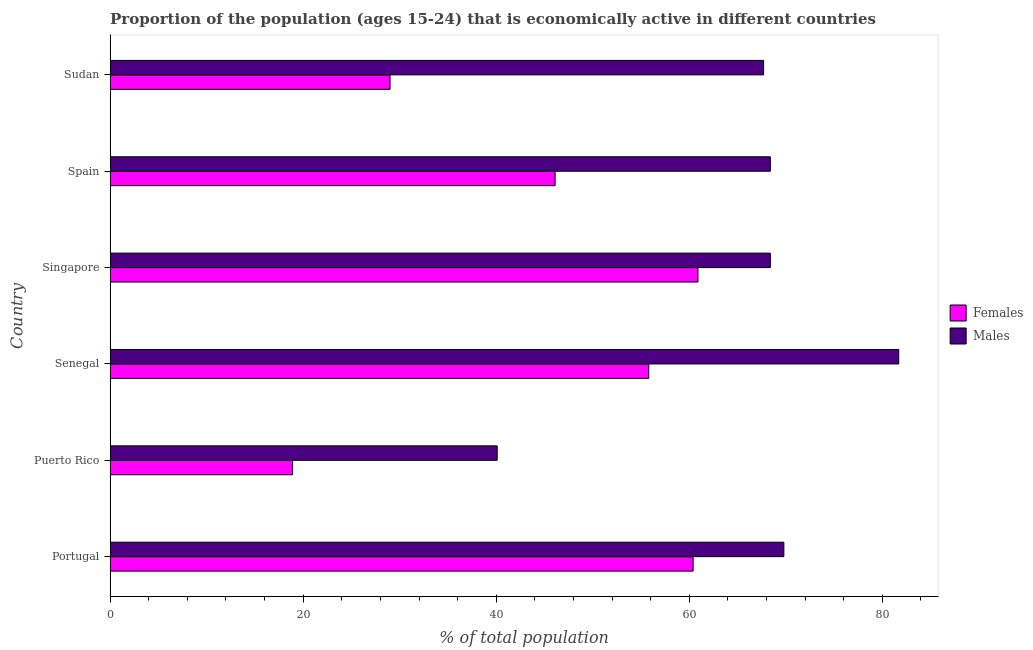How many different coloured bars are there?
Offer a terse response. 2. How many groups of bars are there?
Give a very brief answer. 6. Are the number of bars per tick equal to the number of legend labels?
Give a very brief answer. Yes. How many bars are there on the 6th tick from the top?
Provide a short and direct response. 2. What is the label of the 5th group of bars from the top?
Your answer should be compact. Puerto Rico. In how many cases, is the number of bars for a given country not equal to the number of legend labels?
Your answer should be very brief. 0. What is the percentage of economically active male population in Spain?
Offer a terse response. 68.4. Across all countries, what is the maximum percentage of economically active female population?
Provide a succinct answer. 60.9. Across all countries, what is the minimum percentage of economically active female population?
Make the answer very short. 18.9. In which country was the percentage of economically active male population maximum?
Your answer should be very brief. Senegal. In which country was the percentage of economically active female population minimum?
Ensure brevity in your answer.  Puerto Rico. What is the total percentage of economically active male population in the graph?
Ensure brevity in your answer.  396.1. What is the difference between the percentage of economically active female population in Puerto Rico and that in Spain?
Give a very brief answer. -27.2. What is the difference between the percentage of economically active female population in Sudan and the percentage of economically active male population in Senegal?
Ensure brevity in your answer.  -52.7. What is the average percentage of economically active male population per country?
Provide a short and direct response. 66.02. What is the difference between the percentage of economically active male population and percentage of economically active female population in Sudan?
Your answer should be very brief. 38.7. Is the difference between the percentage of economically active female population in Senegal and Spain greater than the difference between the percentage of economically active male population in Senegal and Spain?
Make the answer very short. No. What is the difference between the highest and the lowest percentage of economically active male population?
Give a very brief answer. 41.6. In how many countries, is the percentage of economically active female population greater than the average percentage of economically active female population taken over all countries?
Make the answer very short. 4. Is the sum of the percentage of economically active male population in Portugal and Senegal greater than the maximum percentage of economically active female population across all countries?
Your answer should be compact. Yes. What does the 2nd bar from the top in Spain represents?
Provide a short and direct response. Females. What does the 1st bar from the bottom in Sudan represents?
Give a very brief answer. Females. How many countries are there in the graph?
Your answer should be compact. 6. Does the graph contain any zero values?
Ensure brevity in your answer.  No. Where does the legend appear in the graph?
Ensure brevity in your answer.  Center right. How many legend labels are there?
Your answer should be compact. 2. What is the title of the graph?
Your answer should be compact. Proportion of the population (ages 15-24) that is economically active in different countries. Does "Overweight" appear as one of the legend labels in the graph?
Your answer should be very brief. No. What is the label or title of the X-axis?
Make the answer very short. % of total population. What is the % of total population of Females in Portugal?
Provide a short and direct response. 60.4. What is the % of total population of Males in Portugal?
Offer a very short reply. 69.8. What is the % of total population in Females in Puerto Rico?
Provide a succinct answer. 18.9. What is the % of total population in Males in Puerto Rico?
Your answer should be very brief. 40.1. What is the % of total population of Females in Senegal?
Ensure brevity in your answer.  55.8. What is the % of total population in Males in Senegal?
Ensure brevity in your answer.  81.7. What is the % of total population in Females in Singapore?
Provide a short and direct response. 60.9. What is the % of total population in Males in Singapore?
Provide a succinct answer. 68.4. What is the % of total population of Females in Spain?
Your response must be concise. 46.1. What is the % of total population in Males in Spain?
Give a very brief answer. 68.4. What is the % of total population in Females in Sudan?
Offer a terse response. 29. What is the % of total population in Males in Sudan?
Your answer should be compact. 67.7. Across all countries, what is the maximum % of total population in Females?
Ensure brevity in your answer.  60.9. Across all countries, what is the maximum % of total population in Males?
Provide a short and direct response. 81.7. Across all countries, what is the minimum % of total population in Females?
Keep it short and to the point. 18.9. Across all countries, what is the minimum % of total population of Males?
Provide a short and direct response. 40.1. What is the total % of total population in Females in the graph?
Your answer should be compact. 271.1. What is the total % of total population in Males in the graph?
Provide a succinct answer. 396.1. What is the difference between the % of total population in Females in Portugal and that in Puerto Rico?
Keep it short and to the point. 41.5. What is the difference between the % of total population of Males in Portugal and that in Puerto Rico?
Provide a succinct answer. 29.7. What is the difference between the % of total population in Females in Portugal and that in Senegal?
Provide a succinct answer. 4.6. What is the difference between the % of total population in Males in Portugal and that in Senegal?
Ensure brevity in your answer.  -11.9. What is the difference between the % of total population in Females in Portugal and that in Singapore?
Offer a terse response. -0.5. What is the difference between the % of total population in Males in Portugal and that in Singapore?
Your answer should be compact. 1.4. What is the difference between the % of total population of Males in Portugal and that in Spain?
Provide a short and direct response. 1.4. What is the difference between the % of total population of Females in Portugal and that in Sudan?
Make the answer very short. 31.4. What is the difference between the % of total population in Females in Puerto Rico and that in Senegal?
Keep it short and to the point. -36.9. What is the difference between the % of total population in Males in Puerto Rico and that in Senegal?
Provide a short and direct response. -41.6. What is the difference between the % of total population of Females in Puerto Rico and that in Singapore?
Provide a short and direct response. -42. What is the difference between the % of total population in Males in Puerto Rico and that in Singapore?
Your response must be concise. -28.3. What is the difference between the % of total population in Females in Puerto Rico and that in Spain?
Ensure brevity in your answer.  -27.2. What is the difference between the % of total population of Males in Puerto Rico and that in Spain?
Your response must be concise. -28.3. What is the difference between the % of total population in Males in Puerto Rico and that in Sudan?
Provide a short and direct response. -27.6. What is the difference between the % of total population in Females in Senegal and that in Singapore?
Keep it short and to the point. -5.1. What is the difference between the % of total population in Females in Senegal and that in Sudan?
Your response must be concise. 26.8. What is the difference between the % of total population in Females in Singapore and that in Sudan?
Your response must be concise. 31.9. What is the difference between the % of total population in Females in Spain and that in Sudan?
Offer a terse response. 17.1. What is the difference between the % of total population in Females in Portugal and the % of total population in Males in Puerto Rico?
Your answer should be compact. 20.3. What is the difference between the % of total population of Females in Portugal and the % of total population of Males in Senegal?
Your response must be concise. -21.3. What is the difference between the % of total population of Females in Portugal and the % of total population of Males in Sudan?
Give a very brief answer. -7.3. What is the difference between the % of total population of Females in Puerto Rico and the % of total population of Males in Senegal?
Provide a succinct answer. -62.8. What is the difference between the % of total population in Females in Puerto Rico and the % of total population in Males in Singapore?
Your answer should be very brief. -49.5. What is the difference between the % of total population of Females in Puerto Rico and the % of total population of Males in Spain?
Your answer should be very brief. -49.5. What is the difference between the % of total population of Females in Puerto Rico and the % of total population of Males in Sudan?
Ensure brevity in your answer.  -48.8. What is the difference between the % of total population in Females in Senegal and the % of total population in Males in Singapore?
Provide a short and direct response. -12.6. What is the difference between the % of total population of Females in Senegal and the % of total population of Males in Spain?
Make the answer very short. -12.6. What is the difference between the % of total population of Females in Senegal and the % of total population of Males in Sudan?
Ensure brevity in your answer.  -11.9. What is the difference between the % of total population of Females in Singapore and the % of total population of Males in Spain?
Make the answer very short. -7.5. What is the difference between the % of total population of Females in Singapore and the % of total population of Males in Sudan?
Make the answer very short. -6.8. What is the difference between the % of total population of Females in Spain and the % of total population of Males in Sudan?
Make the answer very short. -21.6. What is the average % of total population of Females per country?
Offer a terse response. 45.18. What is the average % of total population of Males per country?
Keep it short and to the point. 66.02. What is the difference between the % of total population in Females and % of total population in Males in Portugal?
Your response must be concise. -9.4. What is the difference between the % of total population in Females and % of total population in Males in Puerto Rico?
Your answer should be compact. -21.2. What is the difference between the % of total population of Females and % of total population of Males in Senegal?
Ensure brevity in your answer.  -25.9. What is the difference between the % of total population in Females and % of total population in Males in Singapore?
Your answer should be very brief. -7.5. What is the difference between the % of total population in Females and % of total population in Males in Spain?
Provide a succinct answer. -22.3. What is the difference between the % of total population of Females and % of total population of Males in Sudan?
Offer a terse response. -38.7. What is the ratio of the % of total population in Females in Portugal to that in Puerto Rico?
Your response must be concise. 3.2. What is the ratio of the % of total population in Males in Portugal to that in Puerto Rico?
Give a very brief answer. 1.74. What is the ratio of the % of total population in Females in Portugal to that in Senegal?
Offer a very short reply. 1.08. What is the ratio of the % of total population in Males in Portugal to that in Senegal?
Keep it short and to the point. 0.85. What is the ratio of the % of total population in Males in Portugal to that in Singapore?
Provide a short and direct response. 1.02. What is the ratio of the % of total population of Females in Portugal to that in Spain?
Make the answer very short. 1.31. What is the ratio of the % of total population in Males in Portugal to that in Spain?
Keep it short and to the point. 1.02. What is the ratio of the % of total population of Females in Portugal to that in Sudan?
Provide a succinct answer. 2.08. What is the ratio of the % of total population in Males in Portugal to that in Sudan?
Ensure brevity in your answer.  1.03. What is the ratio of the % of total population of Females in Puerto Rico to that in Senegal?
Offer a very short reply. 0.34. What is the ratio of the % of total population in Males in Puerto Rico to that in Senegal?
Give a very brief answer. 0.49. What is the ratio of the % of total population in Females in Puerto Rico to that in Singapore?
Keep it short and to the point. 0.31. What is the ratio of the % of total population of Males in Puerto Rico to that in Singapore?
Provide a succinct answer. 0.59. What is the ratio of the % of total population in Females in Puerto Rico to that in Spain?
Keep it short and to the point. 0.41. What is the ratio of the % of total population in Males in Puerto Rico to that in Spain?
Make the answer very short. 0.59. What is the ratio of the % of total population in Females in Puerto Rico to that in Sudan?
Make the answer very short. 0.65. What is the ratio of the % of total population in Males in Puerto Rico to that in Sudan?
Your answer should be very brief. 0.59. What is the ratio of the % of total population of Females in Senegal to that in Singapore?
Your answer should be very brief. 0.92. What is the ratio of the % of total population of Males in Senegal to that in Singapore?
Offer a terse response. 1.19. What is the ratio of the % of total population in Females in Senegal to that in Spain?
Provide a short and direct response. 1.21. What is the ratio of the % of total population in Males in Senegal to that in Spain?
Provide a short and direct response. 1.19. What is the ratio of the % of total population in Females in Senegal to that in Sudan?
Ensure brevity in your answer.  1.92. What is the ratio of the % of total population of Males in Senegal to that in Sudan?
Ensure brevity in your answer.  1.21. What is the ratio of the % of total population in Females in Singapore to that in Spain?
Ensure brevity in your answer.  1.32. What is the ratio of the % of total population in Males in Singapore to that in Sudan?
Keep it short and to the point. 1.01. What is the ratio of the % of total population in Females in Spain to that in Sudan?
Offer a terse response. 1.59. What is the ratio of the % of total population of Males in Spain to that in Sudan?
Ensure brevity in your answer.  1.01. What is the difference between the highest and the lowest % of total population in Males?
Ensure brevity in your answer.  41.6. 